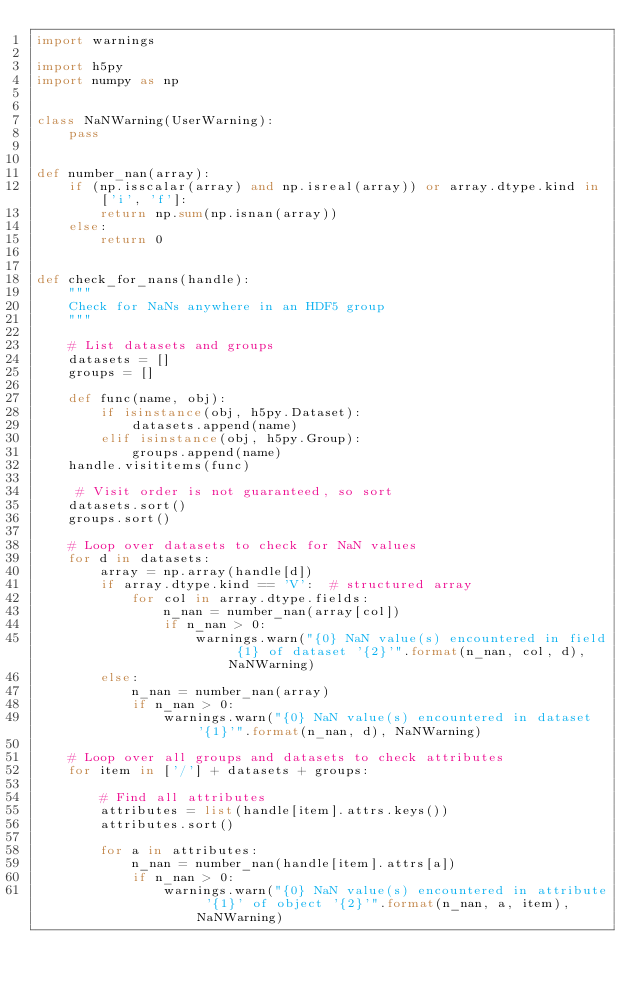Convert code to text. <code><loc_0><loc_0><loc_500><loc_500><_Python_>import warnings

import h5py
import numpy as np


class NaNWarning(UserWarning):
    pass


def number_nan(array):
    if (np.isscalar(array) and np.isreal(array)) or array.dtype.kind in ['i', 'f']:
        return np.sum(np.isnan(array))
    else:
        return 0


def check_for_nans(handle):
    """
    Check for NaNs anywhere in an HDF5 group
    """

    # List datasets and groups
    datasets = []
    groups = []

    def func(name, obj):
        if isinstance(obj, h5py.Dataset):
            datasets.append(name)
        elif isinstance(obj, h5py.Group):
            groups.append(name)
    handle.visititems(func)

     # Visit order is not guaranteed, so sort
    datasets.sort()
    groups.sort()

    # Loop over datasets to check for NaN values
    for d in datasets:
        array = np.array(handle[d])
        if array.dtype.kind == 'V':  # structured array
            for col in array.dtype.fields:
                n_nan = number_nan(array[col])
                if n_nan > 0:
                    warnings.warn("{0} NaN value(s) encountered in field {1} of dataset '{2}'".format(n_nan, col, d), NaNWarning)
        else:
            n_nan = number_nan(array)
            if n_nan > 0:
                warnings.warn("{0} NaN value(s) encountered in dataset '{1}'".format(n_nan, d), NaNWarning)

    # Loop over all groups and datasets to check attributes
    for item in ['/'] + datasets + groups:

        # Find all attributes
        attributes = list(handle[item].attrs.keys())
        attributes.sort()

        for a in attributes:
            n_nan = number_nan(handle[item].attrs[a])
            if n_nan > 0:
                warnings.warn("{0} NaN value(s) encountered in attribute '{1}' of object '{2}'".format(n_nan, a, item), NaNWarning)
</code> 